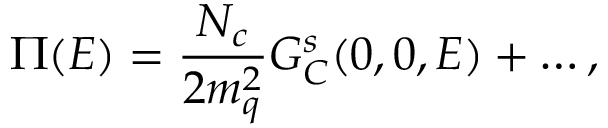<formula> <loc_0><loc_0><loc_500><loc_500>\Pi ( E ) = { \frac { N _ { c } } { 2 m _ { q } ^ { 2 } } } G _ { C } ^ { s } ( 0 , 0 , E ) + \dots ,</formula> 